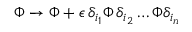Convert formula to latex. <formula><loc_0><loc_0><loc_500><loc_500>\Phi \rightarrow \Phi + \epsilon \, \delta _ { i _ { 1 } } \Phi \, \delta _ { i _ { 2 } } \dots \Phi \delta _ { i _ { n } }</formula> 